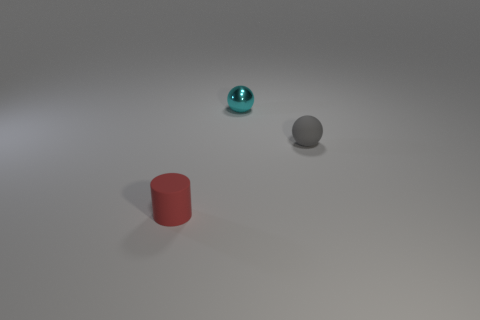Add 3 small red matte spheres. How many objects exist? 6 Subtract all cylinders. How many objects are left? 2 Add 3 shiny objects. How many shiny objects exist? 4 Subtract 0 green spheres. How many objects are left? 3 Subtract all gray matte balls. Subtract all red matte cylinders. How many objects are left? 1 Add 1 tiny cylinders. How many tiny cylinders are left? 2 